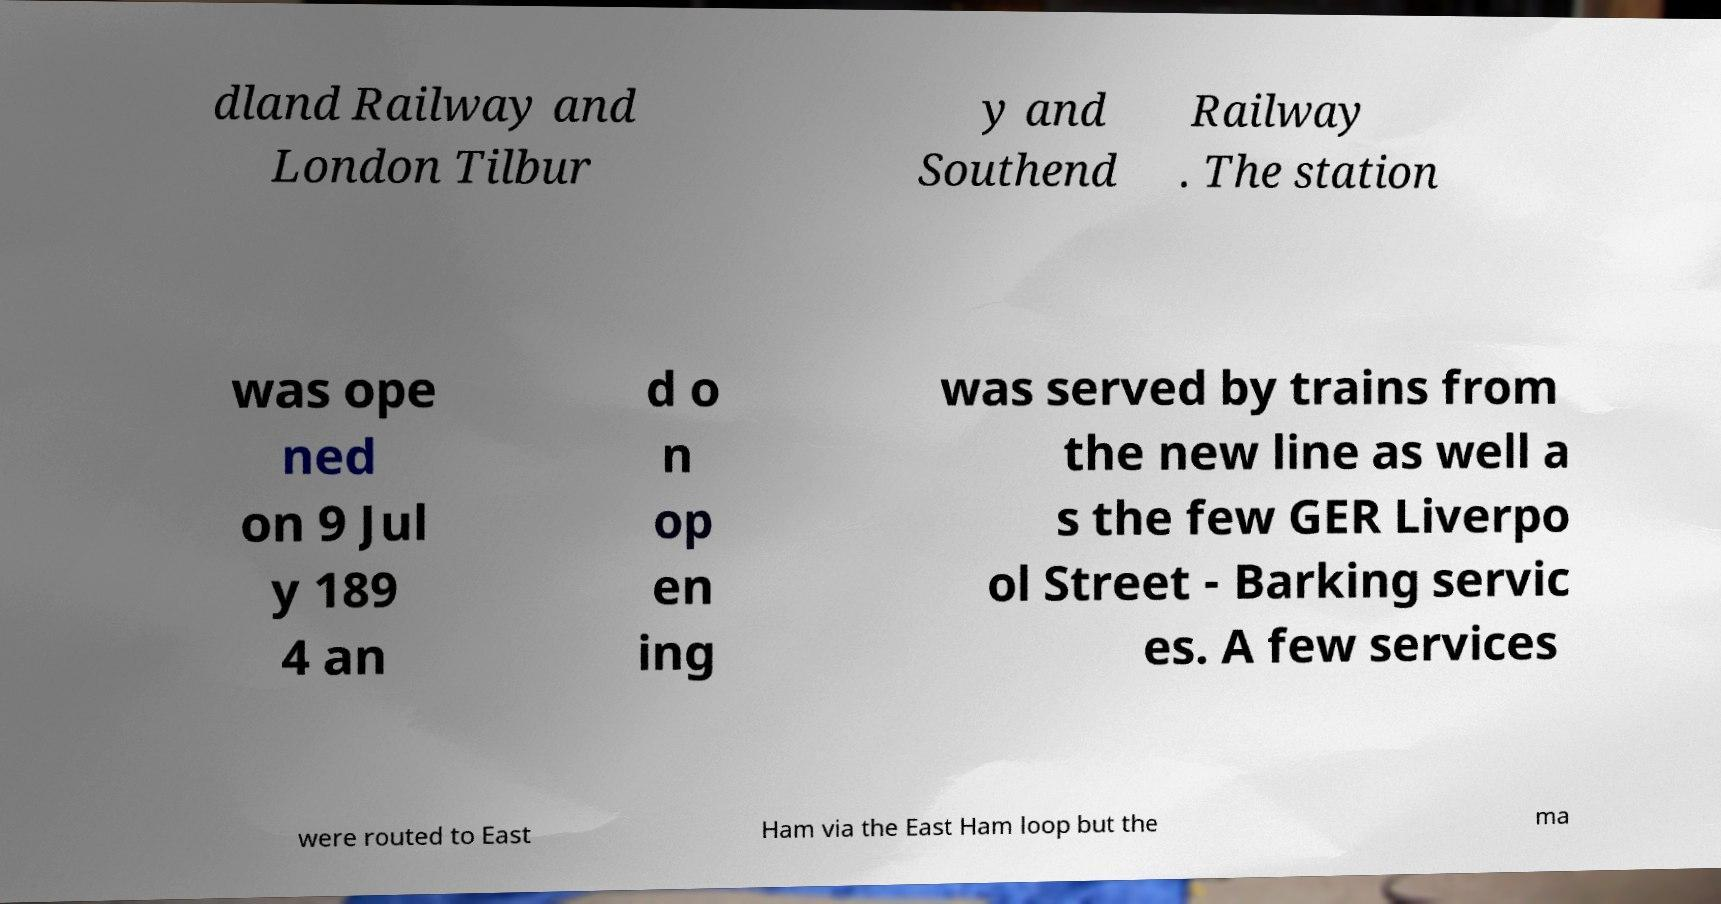What messages or text are displayed in this image? I need them in a readable, typed format. dland Railway and London Tilbur y and Southend Railway . The station was ope ned on 9 Jul y 189 4 an d o n op en ing was served by trains from the new line as well a s the few GER Liverpo ol Street - Barking servic es. A few services were routed to East Ham via the East Ham loop but the ma 